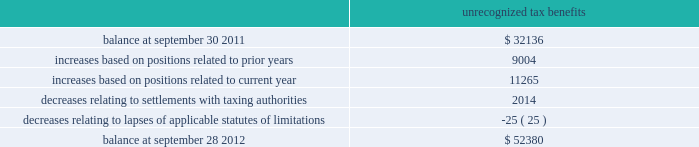Skyworks solutions , inc .
Notes to consolidated financial statements 2014 ( continued ) maintained a valuation allowance of $ 47.0 million .
This valuation allowance is comprised of $ 33.6 million related to u.s .
State tax credits , of which $ 3.6 million are state tax credits acquired from aati in fiscal year 2012 , and $ 13.4 million related to foreign deferred tax assets .
If these benefits are recognized in a future period the valuation allowance on deferred tax assets will be reversed and up to a $ 46.6 million income tax benefit , and up to a $ 0.4 million reduction to goodwill may be recognized .
The company will need to generate $ 209.0 million of future united states federal taxable income to utilize our united states deferred tax assets as of september 28 , 2012 .
Deferred tax assets are recognized for foreign operations when management believes it is more likely than not that the deferred tax assets will be recovered during the carry forward period .
The company will continue to assess its valuation allowance in future periods .
As of september 28 , 2012 , the company has united states federal net operating loss carry forwards of approximately $ 74.3 million , including $ 29.5 million related to the acquisition of sige , which will expire at various dates through 2030 and $ 28.1 million related to the acquisition of aati , which will expire at various dates through 2031 .
The utilization of these net operating losses is subject to certain annual limitations as required under internal revenue code section 382 and similar state income tax provisions .
The company also has united states federal income tax credit carry forwards of $ 37.8 million , of which $ 30.4 million of federal income tax credit carry forwards have not been recorded as a deferred tax asset .
The company also has state income tax credit carry forwards of $ 33.6 million , for which the company has provided a valuation allowance .
The united states federal tax credits expire at various dates through 2032 .
The state tax credits relate primarily to california research tax credits which can be carried forward indefinitely .
The company has continued to expand its operations and increase its investments in numerous international jurisdictions .
These activities will increase the company 2019s earnings attributable to foreign jurisdictions .
As of september 28 , 2012 , no provision has been made for united states federal , state , or additional foreign income taxes related to approximately $ 371.5 million of undistributed earnings of foreign subsidiaries which have been or are intended to be permanently reinvested .
It is not practicable to determine the united states federal income tax liability , if any , which would be payable if such earnings were not permanently reinvested .
The company 2019s gross unrecognized tax benefits totaled $ 52.4 million and $ 32.1 million as of september 28 , 2012 and september 30 , 2011 , respectively .
Of the total unrecognized tax benefits at september 28 , 2012 , $ 38.8 million would impact the effective tax rate , if recognized .
The remaining unrecognized tax benefits would not impact the effective tax rate , if recognized , due to the company 2019s valuation allowance and certain positions which were required to be capitalized .
There are no positions which the company anticipates could change within the next twelve months .
A reconciliation of the beginning and ending amount of gross unrecognized tax benefits is as follows ( in thousands ) : unrecognized tax benefits .
Page 114 annual report .
What amount of unrecognized tax benefits would not impact the effective tax rate , ( in millions ) ? 
Computations: (52.4 - 38.8)
Answer: 13.6. 